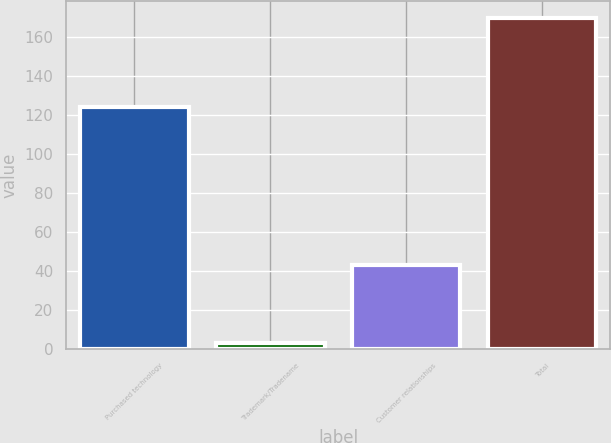Convert chart. <chart><loc_0><loc_0><loc_500><loc_500><bar_chart><fcel>Purchased technology<fcel>Trademark/Tradename<fcel>Customer relationships<fcel>Total<nl><fcel>124<fcel>3<fcel>43<fcel>170<nl></chart> 